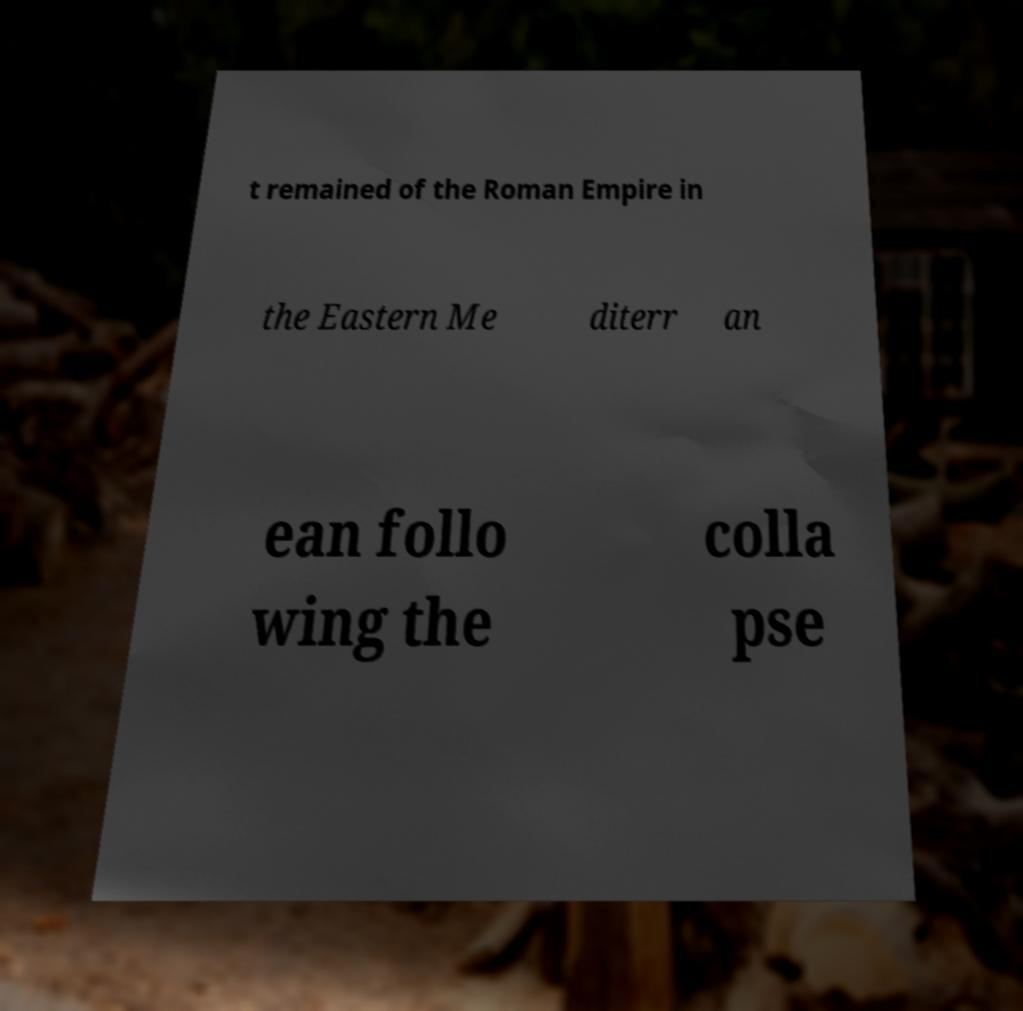What messages or text are displayed in this image? I need them in a readable, typed format. t remained of the Roman Empire in the Eastern Me diterr an ean follo wing the colla pse 